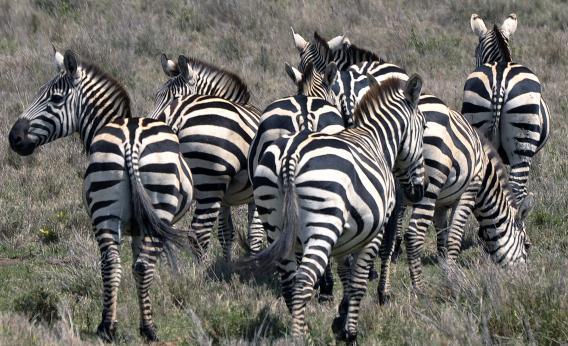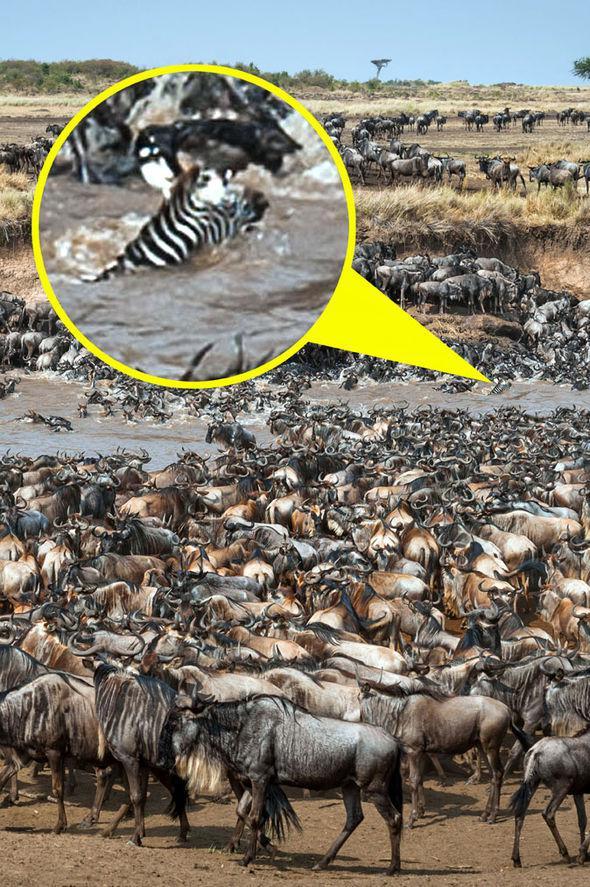The first image is the image on the left, the second image is the image on the right. Given the left and right images, does the statement "The left image shows zebras splashing as they run rightward through water, and the image features only zebra-type animals." hold true? Answer yes or no. No. 